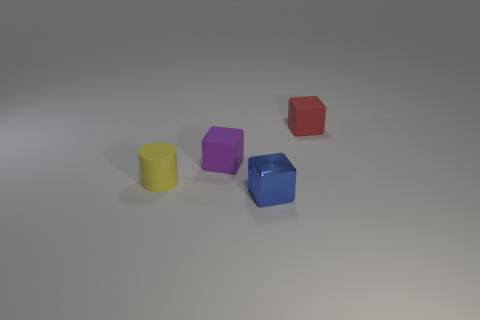There is a block in front of the matte cylinder; is its size the same as the yellow cylinder?
Make the answer very short. Yes. How many other objects are the same material as the purple block?
Your response must be concise. 2. Are there the same number of small rubber blocks that are in front of the tiny metallic object and matte cylinders that are to the right of the tiny red thing?
Your response must be concise. Yes. What is the color of the matte cube in front of the small rubber cube to the right of the tiny cube that is in front of the yellow matte cylinder?
Offer a very short reply. Purple. The object that is in front of the tiny yellow rubber object has what shape?
Your response must be concise. Cube. The tiny yellow object that is made of the same material as the red cube is what shape?
Offer a very short reply. Cylinder. Is there anything else that is the same shape as the small blue object?
Your response must be concise. Yes. There is a red cube; what number of matte things are left of it?
Provide a succinct answer. 2. Are there the same number of tiny cylinders to the right of the red matte object and blue metal objects?
Provide a succinct answer. No. Does the cylinder have the same material as the tiny red thing?
Provide a short and direct response. Yes. 